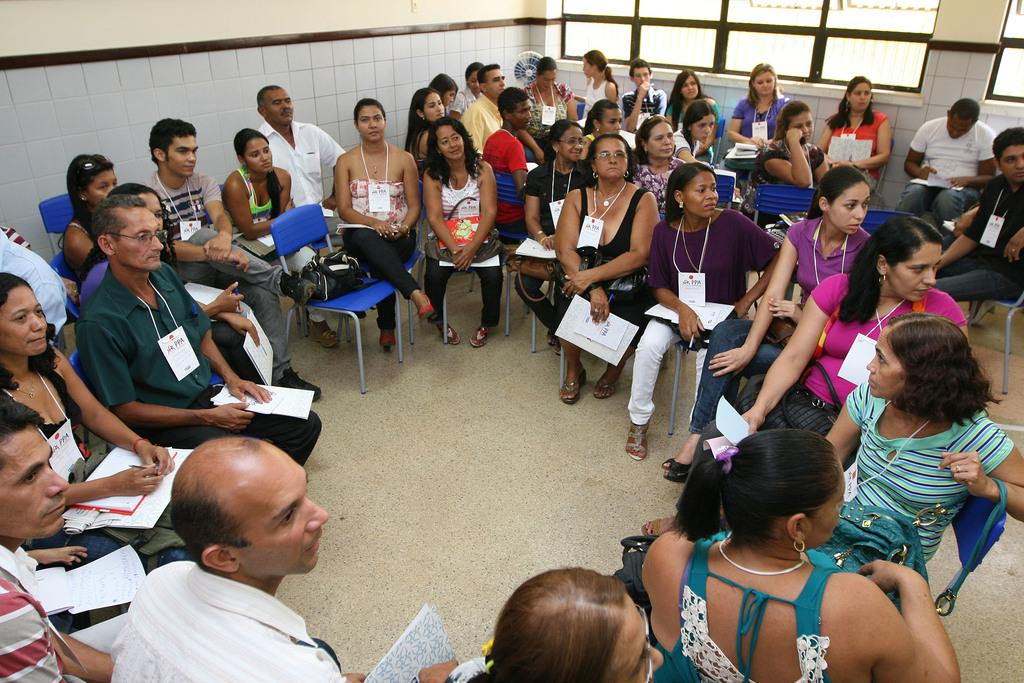Who or what can be seen in the image? There are people in the image. What are the people doing in the image? The people are sitting on chairs. What might the people be holding in their hands? Some of the people are holding papers in their hands. What type of whistle can be heard in the image? There is no whistle present in the image, and therefore no sound can be heard. 